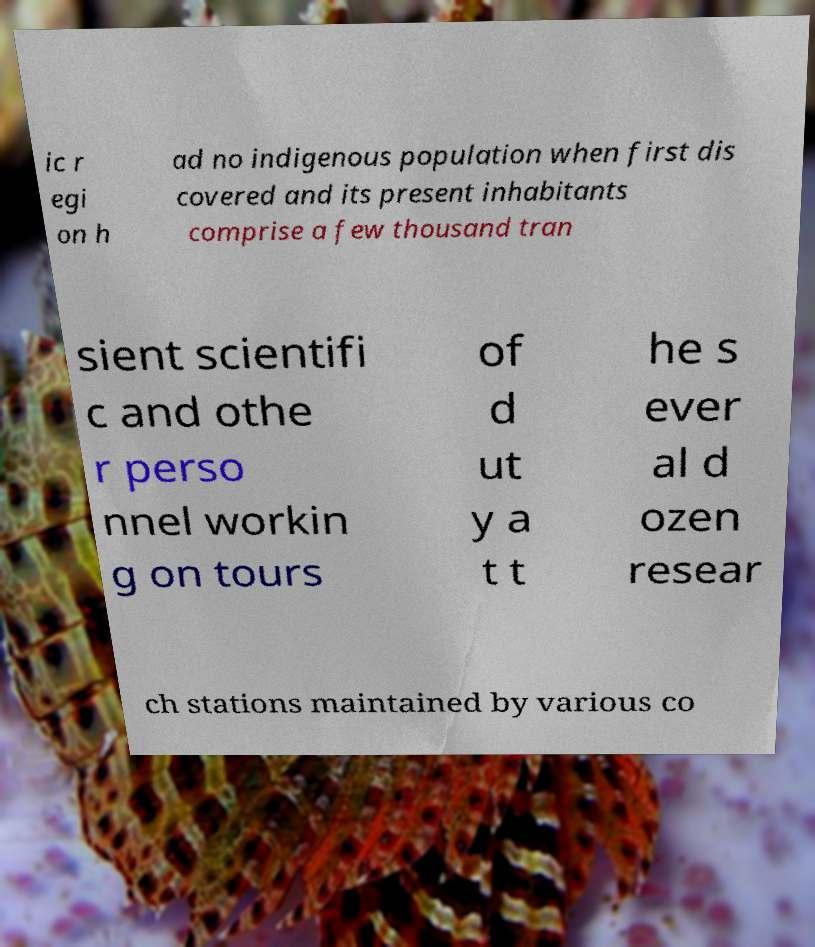I need the written content from this picture converted into text. Can you do that? ic r egi on h ad no indigenous population when first dis covered and its present inhabitants comprise a few thousand tran sient scientifi c and othe r perso nnel workin g on tours of d ut y a t t he s ever al d ozen resear ch stations maintained by various co 